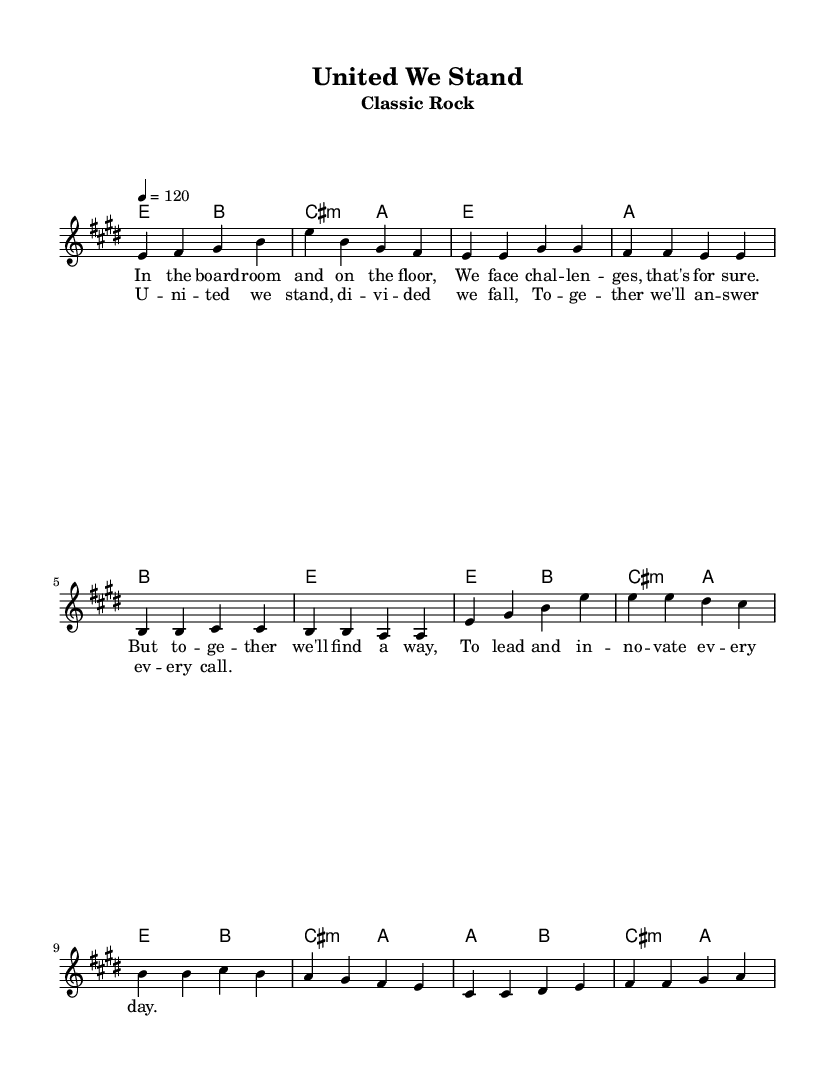What is the key signature of this music? The key signature is E major, which consists of four sharps (F#, C#, G#, D#).
Answer: E major What is the time signature of this music? The time signature shown is 4/4, which means there are four beats in each measure and the quarter note gets one beat.
Answer: 4/4 What is the tempo marking for this piece? The tempo marking indicates a speed of 120 beats per minute, which is a moderate tempo.
Answer: 120 How many measures are in the chorus? The chorus consists of four measures, as counted from the music notation provided.
Answer: 4 Which chord is repeated in both the verse and the chorus? The chord E major appears in both sections, underlying the melody consistently throughout the song.
Answer: E What is the first lyric of the verse? The first lyric of the verse is "In the board," which establishes the context of teamwork and leadership in the lyrics.
Answer: In the board What is the structure of the music (e.g., verse-chorus)? The structure is organized into verses and a chorus, with a bridge included, typical for classic rock anthems.
Answer: Verse-Chorus 